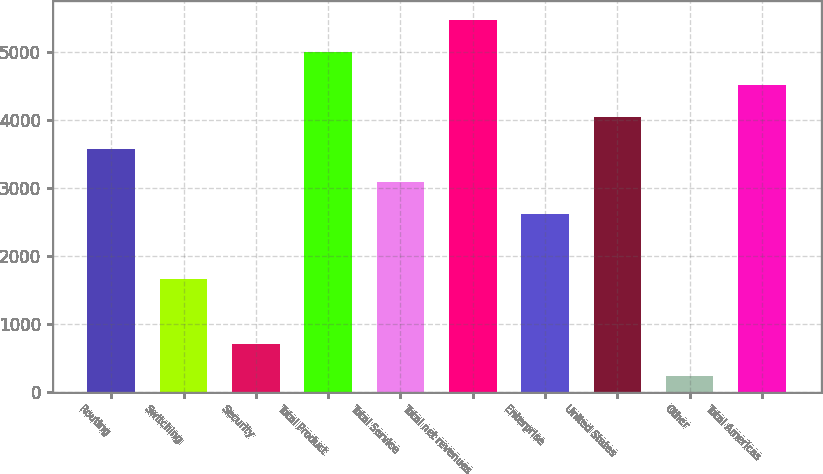Convert chart to OTSL. <chart><loc_0><loc_0><loc_500><loc_500><bar_chart><fcel>Routing<fcel>Switching<fcel>Security<fcel>Total Product<fcel>Total Service<fcel>Total net revenues<fcel>Enterprise<fcel>United States<fcel>Other<fcel>Total Americas<nl><fcel>3562.61<fcel>1659.29<fcel>707.63<fcel>4990.1<fcel>3086.78<fcel>5465.93<fcel>2610.95<fcel>4038.44<fcel>231.8<fcel>4514.27<nl></chart> 